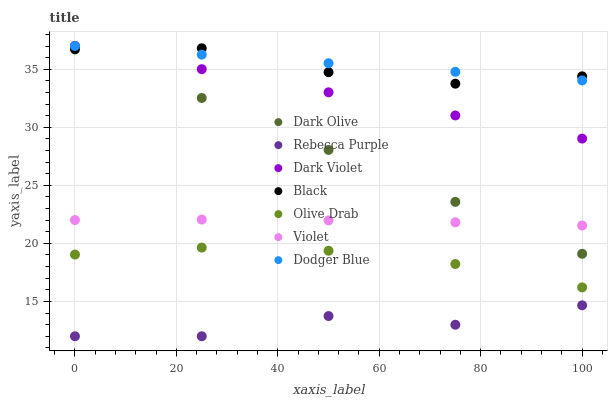Does Rebecca Purple have the minimum area under the curve?
Answer yes or no. Yes. Does Dodger Blue have the maximum area under the curve?
Answer yes or no. Yes. Does Dark Violet have the minimum area under the curve?
Answer yes or no. No. Does Dark Violet have the maximum area under the curve?
Answer yes or no. No. Is Dodger Blue the smoothest?
Answer yes or no. Yes. Is Rebecca Purple the roughest?
Answer yes or no. Yes. Is Dark Violet the smoothest?
Answer yes or no. No. Is Dark Violet the roughest?
Answer yes or no. No. Does Rebecca Purple have the lowest value?
Answer yes or no. Yes. Does Dark Violet have the lowest value?
Answer yes or no. No. Does Dodger Blue have the highest value?
Answer yes or no. Yes. Does Black have the highest value?
Answer yes or no. No. Is Rebecca Purple less than Dark Violet?
Answer yes or no. Yes. Is Dark Olive greater than Olive Drab?
Answer yes or no. Yes. Does Black intersect Dodger Blue?
Answer yes or no. Yes. Is Black less than Dodger Blue?
Answer yes or no. No. Is Black greater than Dodger Blue?
Answer yes or no. No. Does Rebecca Purple intersect Dark Violet?
Answer yes or no. No. 